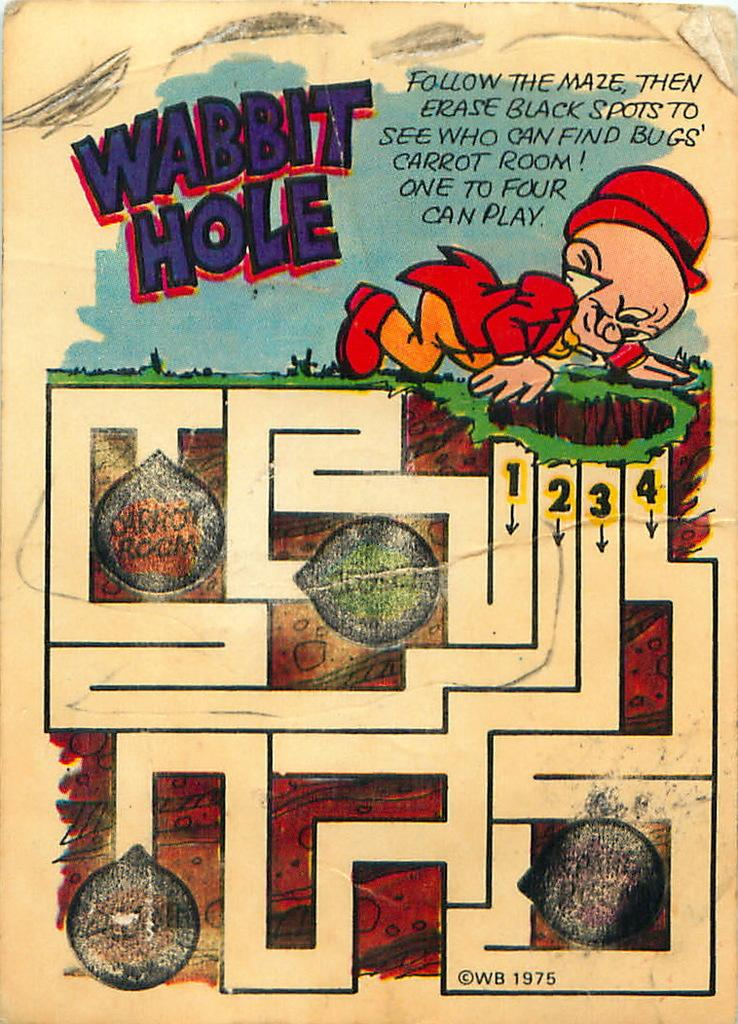<image>
Give a short and clear explanation of the subsequent image. A Bugs Bunny themed maze for children is titled Wabbit Hole. 